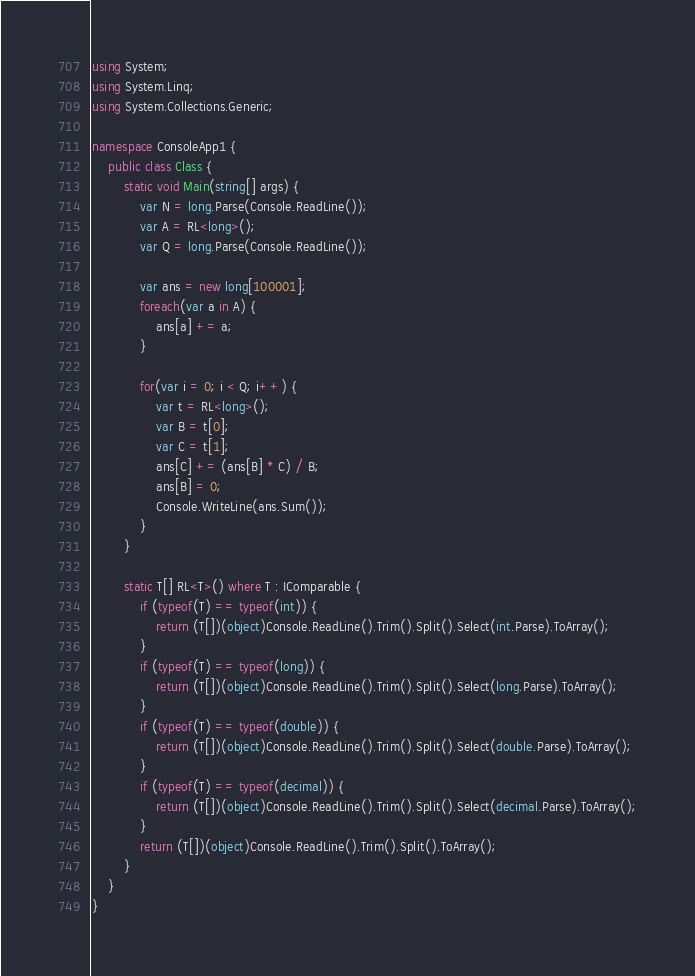<code> <loc_0><loc_0><loc_500><loc_500><_C#_>using System;
using System.Linq;
using System.Collections.Generic;

namespace ConsoleApp1 {
    public class Class {
        static void Main(string[] args) {
            var N = long.Parse(Console.ReadLine());
            var A = RL<long>();
            var Q = long.Parse(Console.ReadLine());

            var ans = new long[100001];
            foreach(var a in A) {
                ans[a] += a;
            }

            for(var i = 0; i < Q; i++) {
                var t = RL<long>();
                var B = t[0];
                var C = t[1];
                ans[C] += (ans[B] * C) / B;
                ans[B] = 0;
                Console.WriteLine(ans.Sum());
            }
        }

        static T[] RL<T>() where T : IComparable {
            if (typeof(T) == typeof(int)) {
                return (T[])(object)Console.ReadLine().Trim().Split().Select(int.Parse).ToArray();
            }
            if (typeof(T) == typeof(long)) {
                return (T[])(object)Console.ReadLine().Trim().Split().Select(long.Parse).ToArray();
            }
            if (typeof(T) == typeof(double)) {
                return (T[])(object)Console.ReadLine().Trim().Split().Select(double.Parse).ToArray();
            }
            if (typeof(T) == typeof(decimal)) {
                return (T[])(object)Console.ReadLine().Trim().Split().Select(decimal.Parse).ToArray();
            }
            return (T[])(object)Console.ReadLine().Trim().Split().ToArray();
        }
    }
}</code> 